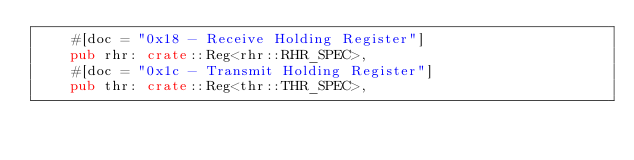<code> <loc_0><loc_0><loc_500><loc_500><_Rust_>    #[doc = "0x18 - Receive Holding Register"]
    pub rhr: crate::Reg<rhr::RHR_SPEC>,
    #[doc = "0x1c - Transmit Holding Register"]
    pub thr: crate::Reg<thr::THR_SPEC>,</code> 